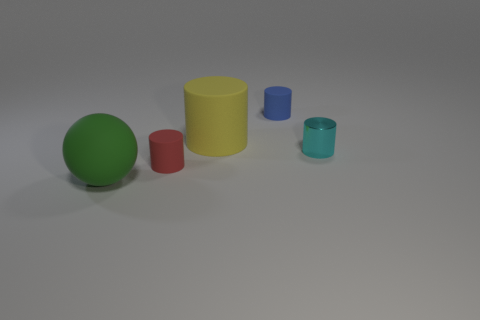Subtract all blue cylinders. Subtract all red balls. How many cylinders are left? 3 Add 1 tiny blue matte cylinders. How many objects exist? 6 Subtract all cylinders. How many objects are left? 1 Subtract 0 cyan blocks. How many objects are left? 5 Subtract all rubber spheres. Subtract all small green matte blocks. How many objects are left? 4 Add 1 big green matte balls. How many big green matte balls are left? 2 Add 1 metallic cylinders. How many metallic cylinders exist? 2 